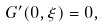<formula> <loc_0><loc_0><loc_500><loc_500>G ^ { \prime } ( 0 , \xi ) = 0 ,</formula> 